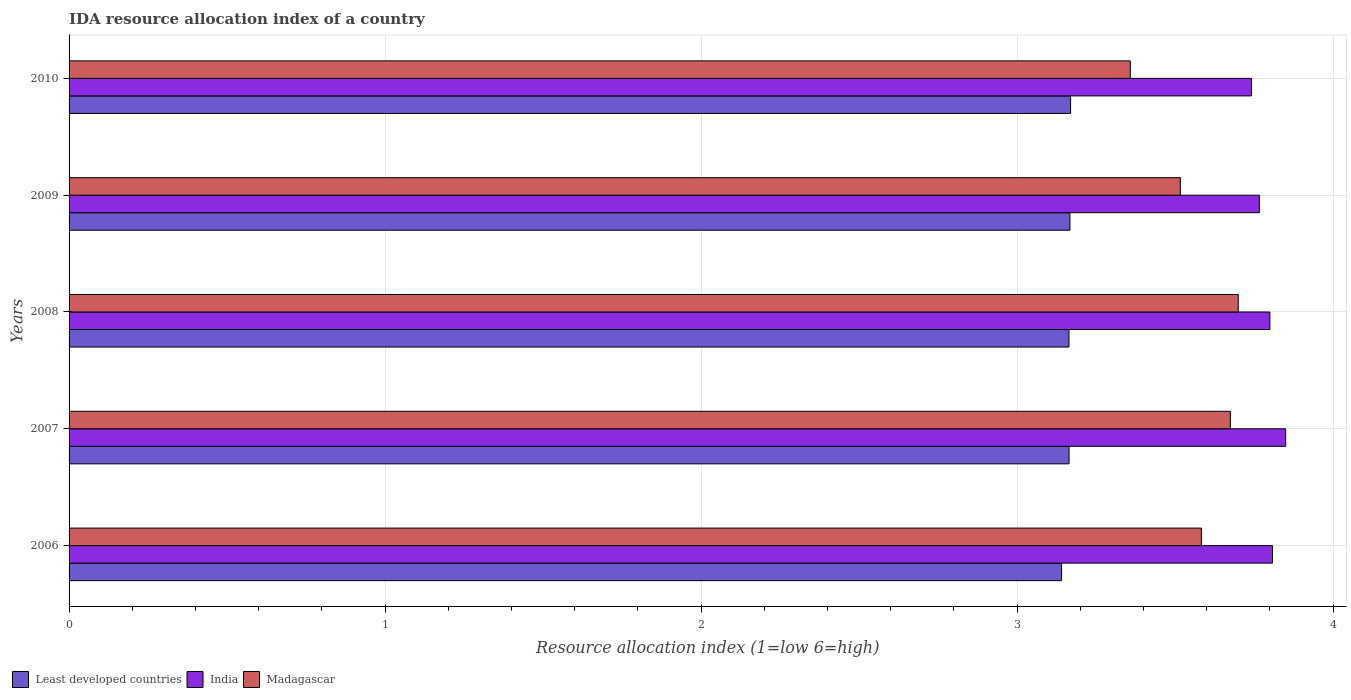Are the number of bars per tick equal to the number of legend labels?
Make the answer very short. Yes. How many bars are there on the 5th tick from the bottom?
Keep it short and to the point. 3. What is the label of the 2nd group of bars from the top?
Provide a short and direct response. 2009. What is the IDA resource allocation index in Least developed countries in 2006?
Make the answer very short. 3.14. Across all years, what is the maximum IDA resource allocation index in Least developed countries?
Provide a short and direct response. 3.17. Across all years, what is the minimum IDA resource allocation index in Madagascar?
Offer a very short reply. 3.36. In which year was the IDA resource allocation index in Least developed countries maximum?
Your response must be concise. 2010. In which year was the IDA resource allocation index in Least developed countries minimum?
Make the answer very short. 2006. What is the total IDA resource allocation index in India in the graph?
Make the answer very short. 18.97. What is the difference between the IDA resource allocation index in India in 2007 and that in 2009?
Ensure brevity in your answer.  0.08. What is the difference between the IDA resource allocation index in India in 2010 and the IDA resource allocation index in Least developed countries in 2007?
Keep it short and to the point. 0.58. What is the average IDA resource allocation index in Least developed countries per year?
Make the answer very short. 3.16. In the year 2007, what is the difference between the IDA resource allocation index in Least developed countries and IDA resource allocation index in Madagascar?
Your response must be concise. -0.51. What is the ratio of the IDA resource allocation index in Least developed countries in 2009 to that in 2010?
Keep it short and to the point. 1. What is the difference between the highest and the second highest IDA resource allocation index in Madagascar?
Keep it short and to the point. 0.03. What is the difference between the highest and the lowest IDA resource allocation index in Least developed countries?
Give a very brief answer. 0.03. In how many years, is the IDA resource allocation index in Madagascar greater than the average IDA resource allocation index in Madagascar taken over all years?
Make the answer very short. 3. What does the 2nd bar from the bottom in 2009 represents?
Offer a very short reply. India. Are all the bars in the graph horizontal?
Your answer should be compact. Yes. How many years are there in the graph?
Keep it short and to the point. 5. Are the values on the major ticks of X-axis written in scientific E-notation?
Keep it short and to the point. No. Where does the legend appear in the graph?
Offer a very short reply. Bottom left. How many legend labels are there?
Your answer should be very brief. 3. How are the legend labels stacked?
Give a very brief answer. Horizontal. What is the title of the graph?
Provide a short and direct response. IDA resource allocation index of a country. Does "Montenegro" appear as one of the legend labels in the graph?
Keep it short and to the point. No. What is the label or title of the X-axis?
Your answer should be very brief. Resource allocation index (1=low 6=high). What is the Resource allocation index (1=low 6=high) of Least developed countries in 2006?
Provide a succinct answer. 3.14. What is the Resource allocation index (1=low 6=high) of India in 2006?
Give a very brief answer. 3.81. What is the Resource allocation index (1=low 6=high) in Madagascar in 2006?
Give a very brief answer. 3.58. What is the Resource allocation index (1=low 6=high) of Least developed countries in 2007?
Your answer should be compact. 3.16. What is the Resource allocation index (1=low 6=high) of India in 2007?
Ensure brevity in your answer.  3.85. What is the Resource allocation index (1=low 6=high) of Madagascar in 2007?
Provide a succinct answer. 3.67. What is the Resource allocation index (1=low 6=high) in Least developed countries in 2008?
Offer a very short reply. 3.16. What is the Resource allocation index (1=low 6=high) in Least developed countries in 2009?
Make the answer very short. 3.17. What is the Resource allocation index (1=low 6=high) in India in 2009?
Your response must be concise. 3.77. What is the Resource allocation index (1=low 6=high) of Madagascar in 2009?
Your response must be concise. 3.52. What is the Resource allocation index (1=low 6=high) of Least developed countries in 2010?
Ensure brevity in your answer.  3.17. What is the Resource allocation index (1=low 6=high) of India in 2010?
Give a very brief answer. 3.74. What is the Resource allocation index (1=low 6=high) in Madagascar in 2010?
Your response must be concise. 3.36. Across all years, what is the maximum Resource allocation index (1=low 6=high) in Least developed countries?
Make the answer very short. 3.17. Across all years, what is the maximum Resource allocation index (1=low 6=high) of India?
Offer a terse response. 3.85. Across all years, what is the maximum Resource allocation index (1=low 6=high) in Madagascar?
Provide a short and direct response. 3.7. Across all years, what is the minimum Resource allocation index (1=low 6=high) of Least developed countries?
Your response must be concise. 3.14. Across all years, what is the minimum Resource allocation index (1=low 6=high) of India?
Your answer should be compact. 3.74. Across all years, what is the minimum Resource allocation index (1=low 6=high) of Madagascar?
Your answer should be very brief. 3.36. What is the total Resource allocation index (1=low 6=high) of Least developed countries in the graph?
Ensure brevity in your answer.  15.81. What is the total Resource allocation index (1=low 6=high) of India in the graph?
Ensure brevity in your answer.  18.97. What is the total Resource allocation index (1=low 6=high) in Madagascar in the graph?
Offer a very short reply. 17.83. What is the difference between the Resource allocation index (1=low 6=high) of Least developed countries in 2006 and that in 2007?
Provide a short and direct response. -0.02. What is the difference between the Resource allocation index (1=low 6=high) of India in 2006 and that in 2007?
Your response must be concise. -0.04. What is the difference between the Resource allocation index (1=low 6=high) of Madagascar in 2006 and that in 2007?
Give a very brief answer. -0.09. What is the difference between the Resource allocation index (1=low 6=high) in Least developed countries in 2006 and that in 2008?
Provide a succinct answer. -0.02. What is the difference between the Resource allocation index (1=low 6=high) of India in 2006 and that in 2008?
Your answer should be compact. 0.01. What is the difference between the Resource allocation index (1=low 6=high) in Madagascar in 2006 and that in 2008?
Provide a succinct answer. -0.12. What is the difference between the Resource allocation index (1=low 6=high) in Least developed countries in 2006 and that in 2009?
Offer a very short reply. -0.03. What is the difference between the Resource allocation index (1=low 6=high) in India in 2006 and that in 2009?
Keep it short and to the point. 0.04. What is the difference between the Resource allocation index (1=low 6=high) of Madagascar in 2006 and that in 2009?
Offer a terse response. 0.07. What is the difference between the Resource allocation index (1=low 6=high) of Least developed countries in 2006 and that in 2010?
Provide a succinct answer. -0.03. What is the difference between the Resource allocation index (1=low 6=high) of India in 2006 and that in 2010?
Keep it short and to the point. 0.07. What is the difference between the Resource allocation index (1=low 6=high) in Madagascar in 2006 and that in 2010?
Provide a succinct answer. 0.23. What is the difference between the Resource allocation index (1=low 6=high) of Madagascar in 2007 and that in 2008?
Your answer should be very brief. -0.03. What is the difference between the Resource allocation index (1=low 6=high) of Least developed countries in 2007 and that in 2009?
Your answer should be very brief. -0. What is the difference between the Resource allocation index (1=low 6=high) of India in 2007 and that in 2009?
Ensure brevity in your answer.  0.08. What is the difference between the Resource allocation index (1=low 6=high) of Madagascar in 2007 and that in 2009?
Provide a short and direct response. 0.16. What is the difference between the Resource allocation index (1=low 6=high) in Least developed countries in 2007 and that in 2010?
Provide a succinct answer. -0. What is the difference between the Resource allocation index (1=low 6=high) of India in 2007 and that in 2010?
Make the answer very short. 0.11. What is the difference between the Resource allocation index (1=low 6=high) in Madagascar in 2007 and that in 2010?
Give a very brief answer. 0.32. What is the difference between the Resource allocation index (1=low 6=high) in Least developed countries in 2008 and that in 2009?
Offer a terse response. -0. What is the difference between the Resource allocation index (1=low 6=high) of Madagascar in 2008 and that in 2009?
Make the answer very short. 0.18. What is the difference between the Resource allocation index (1=low 6=high) of Least developed countries in 2008 and that in 2010?
Provide a short and direct response. -0.01. What is the difference between the Resource allocation index (1=low 6=high) in India in 2008 and that in 2010?
Provide a short and direct response. 0.06. What is the difference between the Resource allocation index (1=low 6=high) in Madagascar in 2008 and that in 2010?
Ensure brevity in your answer.  0.34. What is the difference between the Resource allocation index (1=low 6=high) in Least developed countries in 2009 and that in 2010?
Give a very brief answer. -0. What is the difference between the Resource allocation index (1=low 6=high) of India in 2009 and that in 2010?
Make the answer very short. 0.03. What is the difference between the Resource allocation index (1=low 6=high) of Madagascar in 2009 and that in 2010?
Keep it short and to the point. 0.16. What is the difference between the Resource allocation index (1=low 6=high) in Least developed countries in 2006 and the Resource allocation index (1=low 6=high) in India in 2007?
Offer a very short reply. -0.71. What is the difference between the Resource allocation index (1=low 6=high) of Least developed countries in 2006 and the Resource allocation index (1=low 6=high) of Madagascar in 2007?
Offer a terse response. -0.53. What is the difference between the Resource allocation index (1=low 6=high) in India in 2006 and the Resource allocation index (1=low 6=high) in Madagascar in 2007?
Provide a succinct answer. 0.13. What is the difference between the Resource allocation index (1=low 6=high) of Least developed countries in 2006 and the Resource allocation index (1=low 6=high) of India in 2008?
Your answer should be compact. -0.66. What is the difference between the Resource allocation index (1=low 6=high) in Least developed countries in 2006 and the Resource allocation index (1=low 6=high) in Madagascar in 2008?
Your answer should be very brief. -0.56. What is the difference between the Resource allocation index (1=low 6=high) of India in 2006 and the Resource allocation index (1=low 6=high) of Madagascar in 2008?
Your response must be concise. 0.11. What is the difference between the Resource allocation index (1=low 6=high) of Least developed countries in 2006 and the Resource allocation index (1=low 6=high) of India in 2009?
Make the answer very short. -0.63. What is the difference between the Resource allocation index (1=low 6=high) in Least developed countries in 2006 and the Resource allocation index (1=low 6=high) in Madagascar in 2009?
Provide a succinct answer. -0.38. What is the difference between the Resource allocation index (1=low 6=high) in India in 2006 and the Resource allocation index (1=low 6=high) in Madagascar in 2009?
Your answer should be compact. 0.29. What is the difference between the Resource allocation index (1=low 6=high) in Least developed countries in 2006 and the Resource allocation index (1=low 6=high) in India in 2010?
Ensure brevity in your answer.  -0.6. What is the difference between the Resource allocation index (1=low 6=high) of Least developed countries in 2006 and the Resource allocation index (1=low 6=high) of Madagascar in 2010?
Your answer should be very brief. -0.22. What is the difference between the Resource allocation index (1=low 6=high) in India in 2006 and the Resource allocation index (1=low 6=high) in Madagascar in 2010?
Make the answer very short. 0.45. What is the difference between the Resource allocation index (1=low 6=high) of Least developed countries in 2007 and the Resource allocation index (1=low 6=high) of India in 2008?
Offer a terse response. -0.64. What is the difference between the Resource allocation index (1=low 6=high) of Least developed countries in 2007 and the Resource allocation index (1=low 6=high) of Madagascar in 2008?
Offer a very short reply. -0.54. What is the difference between the Resource allocation index (1=low 6=high) in India in 2007 and the Resource allocation index (1=low 6=high) in Madagascar in 2008?
Your response must be concise. 0.15. What is the difference between the Resource allocation index (1=low 6=high) in Least developed countries in 2007 and the Resource allocation index (1=low 6=high) in India in 2009?
Your answer should be very brief. -0.6. What is the difference between the Resource allocation index (1=low 6=high) of Least developed countries in 2007 and the Resource allocation index (1=low 6=high) of Madagascar in 2009?
Keep it short and to the point. -0.35. What is the difference between the Resource allocation index (1=low 6=high) of India in 2007 and the Resource allocation index (1=low 6=high) of Madagascar in 2009?
Provide a succinct answer. 0.33. What is the difference between the Resource allocation index (1=low 6=high) in Least developed countries in 2007 and the Resource allocation index (1=low 6=high) in India in 2010?
Your answer should be very brief. -0.58. What is the difference between the Resource allocation index (1=low 6=high) in Least developed countries in 2007 and the Resource allocation index (1=low 6=high) in Madagascar in 2010?
Ensure brevity in your answer.  -0.19. What is the difference between the Resource allocation index (1=low 6=high) of India in 2007 and the Resource allocation index (1=low 6=high) of Madagascar in 2010?
Ensure brevity in your answer.  0.49. What is the difference between the Resource allocation index (1=low 6=high) in Least developed countries in 2008 and the Resource allocation index (1=low 6=high) in India in 2009?
Ensure brevity in your answer.  -0.6. What is the difference between the Resource allocation index (1=low 6=high) in Least developed countries in 2008 and the Resource allocation index (1=low 6=high) in Madagascar in 2009?
Your answer should be very brief. -0.35. What is the difference between the Resource allocation index (1=low 6=high) of India in 2008 and the Resource allocation index (1=low 6=high) of Madagascar in 2009?
Give a very brief answer. 0.28. What is the difference between the Resource allocation index (1=low 6=high) of Least developed countries in 2008 and the Resource allocation index (1=low 6=high) of India in 2010?
Your answer should be compact. -0.58. What is the difference between the Resource allocation index (1=low 6=high) in Least developed countries in 2008 and the Resource allocation index (1=low 6=high) in Madagascar in 2010?
Your response must be concise. -0.19. What is the difference between the Resource allocation index (1=low 6=high) in India in 2008 and the Resource allocation index (1=low 6=high) in Madagascar in 2010?
Provide a short and direct response. 0.44. What is the difference between the Resource allocation index (1=low 6=high) in Least developed countries in 2009 and the Resource allocation index (1=low 6=high) in India in 2010?
Keep it short and to the point. -0.57. What is the difference between the Resource allocation index (1=low 6=high) of Least developed countries in 2009 and the Resource allocation index (1=low 6=high) of Madagascar in 2010?
Provide a succinct answer. -0.19. What is the difference between the Resource allocation index (1=low 6=high) in India in 2009 and the Resource allocation index (1=low 6=high) in Madagascar in 2010?
Provide a short and direct response. 0.41. What is the average Resource allocation index (1=low 6=high) in Least developed countries per year?
Provide a succinct answer. 3.16. What is the average Resource allocation index (1=low 6=high) in India per year?
Your response must be concise. 3.79. What is the average Resource allocation index (1=low 6=high) of Madagascar per year?
Your response must be concise. 3.57. In the year 2006, what is the difference between the Resource allocation index (1=low 6=high) of Least developed countries and Resource allocation index (1=low 6=high) of India?
Provide a short and direct response. -0.67. In the year 2006, what is the difference between the Resource allocation index (1=low 6=high) of Least developed countries and Resource allocation index (1=low 6=high) of Madagascar?
Your response must be concise. -0.44. In the year 2006, what is the difference between the Resource allocation index (1=low 6=high) in India and Resource allocation index (1=low 6=high) in Madagascar?
Your answer should be very brief. 0.23. In the year 2007, what is the difference between the Resource allocation index (1=low 6=high) of Least developed countries and Resource allocation index (1=low 6=high) of India?
Your answer should be very brief. -0.69. In the year 2007, what is the difference between the Resource allocation index (1=low 6=high) of Least developed countries and Resource allocation index (1=low 6=high) of Madagascar?
Your response must be concise. -0.51. In the year 2007, what is the difference between the Resource allocation index (1=low 6=high) of India and Resource allocation index (1=low 6=high) of Madagascar?
Offer a very short reply. 0.17. In the year 2008, what is the difference between the Resource allocation index (1=low 6=high) in Least developed countries and Resource allocation index (1=low 6=high) in India?
Your answer should be very brief. -0.64. In the year 2008, what is the difference between the Resource allocation index (1=low 6=high) in Least developed countries and Resource allocation index (1=low 6=high) in Madagascar?
Your answer should be compact. -0.54. In the year 2008, what is the difference between the Resource allocation index (1=low 6=high) in India and Resource allocation index (1=low 6=high) in Madagascar?
Offer a terse response. 0.1. In the year 2009, what is the difference between the Resource allocation index (1=low 6=high) in Least developed countries and Resource allocation index (1=low 6=high) in India?
Your answer should be compact. -0.6. In the year 2009, what is the difference between the Resource allocation index (1=low 6=high) of Least developed countries and Resource allocation index (1=low 6=high) of Madagascar?
Ensure brevity in your answer.  -0.35. In the year 2009, what is the difference between the Resource allocation index (1=low 6=high) of India and Resource allocation index (1=low 6=high) of Madagascar?
Your answer should be compact. 0.25. In the year 2010, what is the difference between the Resource allocation index (1=low 6=high) of Least developed countries and Resource allocation index (1=low 6=high) of India?
Your response must be concise. -0.57. In the year 2010, what is the difference between the Resource allocation index (1=low 6=high) of Least developed countries and Resource allocation index (1=low 6=high) of Madagascar?
Offer a very short reply. -0.19. In the year 2010, what is the difference between the Resource allocation index (1=low 6=high) of India and Resource allocation index (1=low 6=high) of Madagascar?
Provide a succinct answer. 0.38. What is the ratio of the Resource allocation index (1=low 6=high) of India in 2006 to that in 2007?
Give a very brief answer. 0.99. What is the ratio of the Resource allocation index (1=low 6=high) of Madagascar in 2006 to that in 2007?
Keep it short and to the point. 0.98. What is the ratio of the Resource allocation index (1=low 6=high) of Least developed countries in 2006 to that in 2008?
Your response must be concise. 0.99. What is the ratio of the Resource allocation index (1=low 6=high) of Madagascar in 2006 to that in 2008?
Provide a succinct answer. 0.97. What is the ratio of the Resource allocation index (1=low 6=high) in Least developed countries in 2006 to that in 2009?
Your response must be concise. 0.99. What is the ratio of the Resource allocation index (1=low 6=high) of India in 2006 to that in 2009?
Your answer should be very brief. 1.01. What is the ratio of the Resource allocation index (1=low 6=high) of Madagascar in 2006 to that in 2009?
Your answer should be compact. 1.02. What is the ratio of the Resource allocation index (1=low 6=high) in India in 2006 to that in 2010?
Your answer should be compact. 1.02. What is the ratio of the Resource allocation index (1=low 6=high) of Madagascar in 2006 to that in 2010?
Ensure brevity in your answer.  1.07. What is the ratio of the Resource allocation index (1=low 6=high) in Least developed countries in 2007 to that in 2008?
Your response must be concise. 1. What is the ratio of the Resource allocation index (1=low 6=high) in India in 2007 to that in 2008?
Your response must be concise. 1.01. What is the ratio of the Resource allocation index (1=low 6=high) of Madagascar in 2007 to that in 2008?
Your response must be concise. 0.99. What is the ratio of the Resource allocation index (1=low 6=high) in India in 2007 to that in 2009?
Provide a short and direct response. 1.02. What is the ratio of the Resource allocation index (1=low 6=high) in Madagascar in 2007 to that in 2009?
Keep it short and to the point. 1.04. What is the ratio of the Resource allocation index (1=low 6=high) in Madagascar in 2007 to that in 2010?
Keep it short and to the point. 1.09. What is the ratio of the Resource allocation index (1=low 6=high) in Least developed countries in 2008 to that in 2009?
Make the answer very short. 1. What is the ratio of the Resource allocation index (1=low 6=high) of India in 2008 to that in 2009?
Your answer should be very brief. 1.01. What is the ratio of the Resource allocation index (1=low 6=high) in Madagascar in 2008 to that in 2009?
Offer a terse response. 1.05. What is the ratio of the Resource allocation index (1=low 6=high) in India in 2008 to that in 2010?
Your response must be concise. 1.02. What is the ratio of the Resource allocation index (1=low 6=high) of Madagascar in 2008 to that in 2010?
Your answer should be compact. 1.1. What is the ratio of the Resource allocation index (1=low 6=high) of Least developed countries in 2009 to that in 2010?
Provide a short and direct response. 1. What is the ratio of the Resource allocation index (1=low 6=high) of Madagascar in 2009 to that in 2010?
Provide a short and direct response. 1.05. What is the difference between the highest and the second highest Resource allocation index (1=low 6=high) in Least developed countries?
Make the answer very short. 0. What is the difference between the highest and the second highest Resource allocation index (1=low 6=high) of India?
Provide a succinct answer. 0.04. What is the difference between the highest and the second highest Resource allocation index (1=low 6=high) of Madagascar?
Make the answer very short. 0.03. What is the difference between the highest and the lowest Resource allocation index (1=low 6=high) of Least developed countries?
Provide a succinct answer. 0.03. What is the difference between the highest and the lowest Resource allocation index (1=low 6=high) of India?
Make the answer very short. 0.11. What is the difference between the highest and the lowest Resource allocation index (1=low 6=high) in Madagascar?
Give a very brief answer. 0.34. 